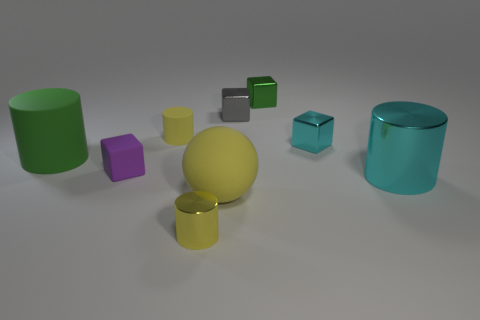Is there any other thing that is the same color as the rubber cube?
Give a very brief answer. No. What is the shape of the cyan thing left of the big metal cylinder?
Give a very brief answer. Cube. How many gray things are the same shape as the small purple rubber thing?
Make the answer very short. 1. What size is the cyan thing on the left side of the large cyan object that is behind the big sphere?
Keep it short and to the point. Small. What number of yellow things are either large matte cylinders or large metallic objects?
Keep it short and to the point. 0. Are there fewer cylinders behind the small rubber cylinder than cylinders on the right side of the yellow metallic cylinder?
Offer a very short reply. Yes. There is a purple rubber object; does it have the same size as the green object that is right of the gray shiny object?
Offer a terse response. Yes. How many purple matte blocks are the same size as the sphere?
Give a very brief answer. 0. What number of tiny objects are either matte cubes or yellow metallic cylinders?
Make the answer very short. 2. Are any big brown cubes visible?
Give a very brief answer. No. 